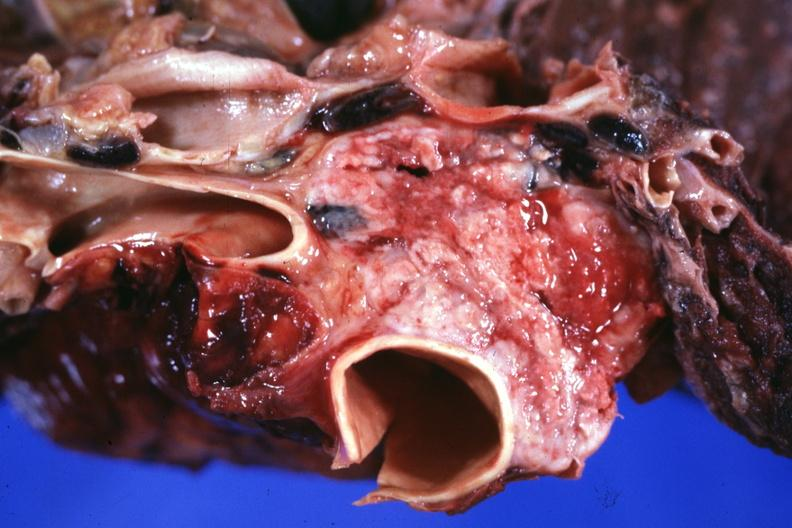s micrognathia triploid fetus present?
Answer the question using a single word or phrase. No 